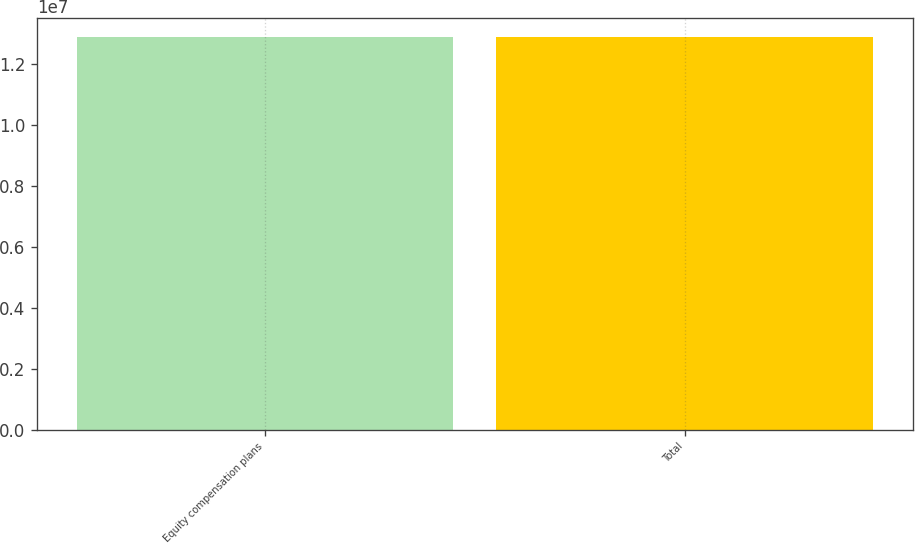Convert chart. <chart><loc_0><loc_0><loc_500><loc_500><bar_chart><fcel>Equity compensation plans<fcel>Total<nl><fcel>1.28756e+07<fcel>1.28756e+07<nl></chart> 